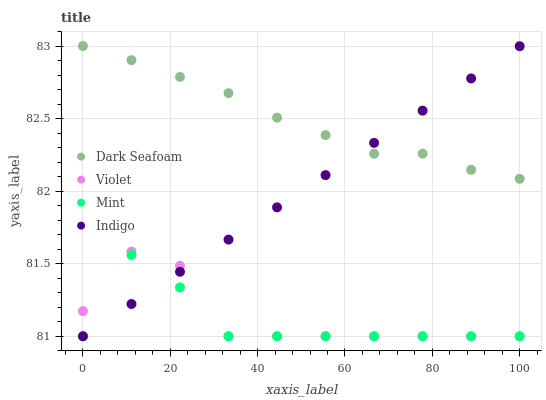Does Mint have the minimum area under the curve?
Answer yes or no. Yes. Does Dark Seafoam have the maximum area under the curve?
Answer yes or no. Yes. Does Dark Seafoam have the minimum area under the curve?
Answer yes or no. No. Does Mint have the maximum area under the curve?
Answer yes or no. No. Is Indigo the smoothest?
Answer yes or no. Yes. Is Violet the roughest?
Answer yes or no. Yes. Is Dark Seafoam the smoothest?
Answer yes or no. No. Is Dark Seafoam the roughest?
Answer yes or no. No. Does Indigo have the lowest value?
Answer yes or no. Yes. Does Dark Seafoam have the lowest value?
Answer yes or no. No. Does Dark Seafoam have the highest value?
Answer yes or no. Yes. Does Mint have the highest value?
Answer yes or no. No. Is Violet less than Dark Seafoam?
Answer yes or no. Yes. Is Dark Seafoam greater than Mint?
Answer yes or no. Yes. Does Dark Seafoam intersect Indigo?
Answer yes or no. Yes. Is Dark Seafoam less than Indigo?
Answer yes or no. No. Is Dark Seafoam greater than Indigo?
Answer yes or no. No. Does Violet intersect Dark Seafoam?
Answer yes or no. No. 